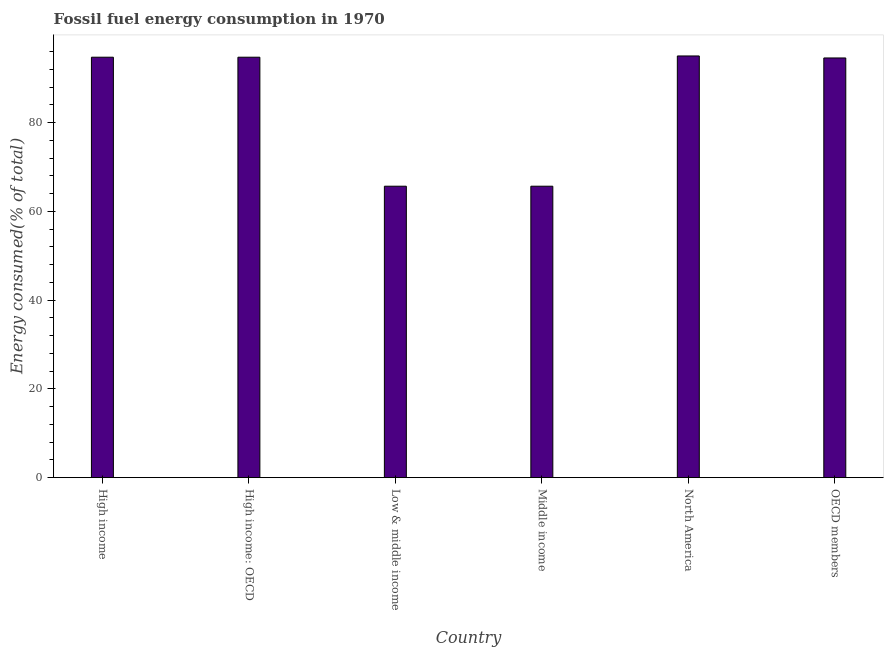What is the title of the graph?
Offer a very short reply. Fossil fuel energy consumption in 1970. What is the label or title of the Y-axis?
Your response must be concise. Energy consumed(% of total). What is the fossil fuel energy consumption in Middle income?
Your answer should be compact. 65.65. Across all countries, what is the maximum fossil fuel energy consumption?
Provide a short and direct response. 95. Across all countries, what is the minimum fossil fuel energy consumption?
Give a very brief answer. 65.65. In which country was the fossil fuel energy consumption maximum?
Your answer should be compact. North America. In which country was the fossil fuel energy consumption minimum?
Offer a very short reply. Low & middle income. What is the sum of the fossil fuel energy consumption?
Make the answer very short. 510.29. What is the difference between the fossil fuel energy consumption in Middle income and North America?
Your response must be concise. -29.34. What is the average fossil fuel energy consumption per country?
Keep it short and to the point. 85.05. What is the median fossil fuel energy consumption?
Ensure brevity in your answer.  94.63. In how many countries, is the fossil fuel energy consumption greater than 60 %?
Your answer should be compact. 6. Is the fossil fuel energy consumption in High income less than that in North America?
Your response must be concise. Yes. Is the difference between the fossil fuel energy consumption in High income and Low & middle income greater than the difference between any two countries?
Give a very brief answer. No. What is the difference between the highest and the second highest fossil fuel energy consumption?
Your answer should be very brief. 0.28. What is the difference between the highest and the lowest fossil fuel energy consumption?
Offer a very short reply. 29.34. In how many countries, is the fossil fuel energy consumption greater than the average fossil fuel energy consumption taken over all countries?
Your answer should be very brief. 4. What is the Energy consumed(% of total) in High income?
Make the answer very short. 94.72. What is the Energy consumed(% of total) in High income: OECD?
Your answer should be very brief. 94.72. What is the Energy consumed(% of total) in Low & middle income?
Your answer should be compact. 65.65. What is the Energy consumed(% of total) of Middle income?
Your answer should be very brief. 65.65. What is the Energy consumed(% of total) in North America?
Your answer should be compact. 95. What is the Energy consumed(% of total) in OECD members?
Ensure brevity in your answer.  94.55. What is the difference between the Energy consumed(% of total) in High income and High income: OECD?
Your response must be concise. 0. What is the difference between the Energy consumed(% of total) in High income and Low & middle income?
Keep it short and to the point. 29.06. What is the difference between the Energy consumed(% of total) in High income and Middle income?
Your answer should be very brief. 29.06. What is the difference between the Energy consumed(% of total) in High income and North America?
Your answer should be very brief. -0.28. What is the difference between the Energy consumed(% of total) in High income and OECD members?
Make the answer very short. 0.17. What is the difference between the Energy consumed(% of total) in High income: OECD and Low & middle income?
Your answer should be very brief. 29.06. What is the difference between the Energy consumed(% of total) in High income: OECD and Middle income?
Your answer should be very brief. 29.06. What is the difference between the Energy consumed(% of total) in High income: OECD and North America?
Provide a succinct answer. -0.28. What is the difference between the Energy consumed(% of total) in High income: OECD and OECD members?
Give a very brief answer. 0.17. What is the difference between the Energy consumed(% of total) in Low & middle income and North America?
Your answer should be very brief. -29.34. What is the difference between the Energy consumed(% of total) in Low & middle income and OECD members?
Make the answer very short. -28.89. What is the difference between the Energy consumed(% of total) in Middle income and North America?
Your response must be concise. -29.34. What is the difference between the Energy consumed(% of total) in Middle income and OECD members?
Keep it short and to the point. -28.89. What is the difference between the Energy consumed(% of total) in North America and OECD members?
Provide a short and direct response. 0.45. What is the ratio of the Energy consumed(% of total) in High income to that in Low & middle income?
Offer a very short reply. 1.44. What is the ratio of the Energy consumed(% of total) in High income to that in Middle income?
Your response must be concise. 1.44. What is the ratio of the Energy consumed(% of total) in High income to that in OECD members?
Offer a very short reply. 1. What is the ratio of the Energy consumed(% of total) in High income: OECD to that in Low & middle income?
Make the answer very short. 1.44. What is the ratio of the Energy consumed(% of total) in High income: OECD to that in Middle income?
Keep it short and to the point. 1.44. What is the ratio of the Energy consumed(% of total) in Low & middle income to that in North America?
Make the answer very short. 0.69. What is the ratio of the Energy consumed(% of total) in Low & middle income to that in OECD members?
Your answer should be very brief. 0.69. What is the ratio of the Energy consumed(% of total) in Middle income to that in North America?
Provide a short and direct response. 0.69. What is the ratio of the Energy consumed(% of total) in Middle income to that in OECD members?
Give a very brief answer. 0.69. 